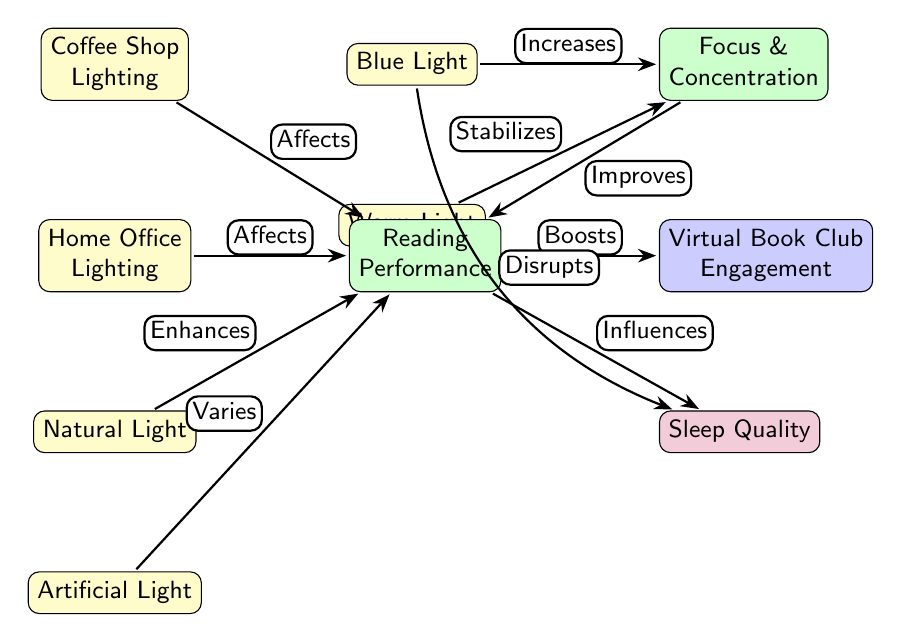What influences sleep quality? According to the diagram, sleep quality is influenced by reading performance. Additionally, blue light is also indicated to disrupt sleep quality. Therefore, the relevant connections state "Influences" and "Disrupts."
Answer: Reading Performance How many lighting conditions are mentioned in the diagram? The diagram includes four lighting conditions: Coffee Shop Lighting, Home Office Lighting, Natural Light, and Artificial Light. Therefore, counting them gives a total of four.
Answer: 4 What relationship do warm light and focus have? The diagram illustrates that warm light stabilizes focus and concentration, which is shown through the arrow labeled "Stabilizes" from warm light to focus.
Answer: Stabilizes What effect does natural light have on reading performance? Natural light is shown in the diagram as enhancing reading performance, indicated by the arrow labeled "Enhances" going from natural light to reading performance.
Answer: Enhances How does reading performance affect virtual book club engagement? The diagram indicates a direct relationship where reading performance boosts virtual book club engagement, as shown by the arrow labeled "Boosts" points from reading performance to virtual book club engagement.
Answer: Boosts What impact does blue light have on focus? The diagram shows a positive relationship, indicating that blue light increases focus and concentration, indicated by the arrow labeled "Increases" pointing from blue light to focus.
Answer: Increases Does artificial light have a defined effect on reading performance? Yes, the diagram states that artificial light varies in its effects on reading performance, which is shown by the relationship described with the word "Varies."
Answer: Varies Which lighting condition is at the bottom of the hierarchy in the diagram? The node at the very bottom is artificial light, meaning it's the last condition referenced concerning the impact on reading and learning.
Answer: Artificial Light 